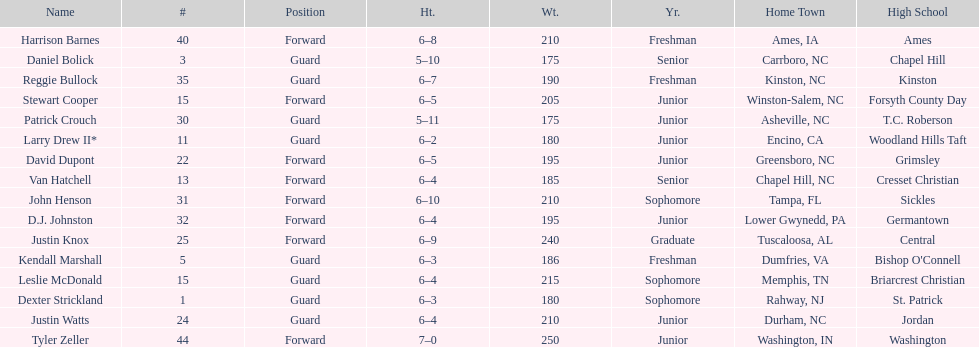Total number of players whose home town was in north carolina (nc) 7. 